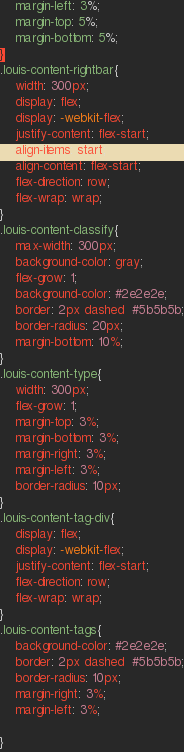<code> <loc_0><loc_0><loc_500><loc_500><_CSS_>    margin-left: 3%;
    margin-top: 5%;
    margin-bottom: 5%;
}
.louis-content-rightbar{
    width: 300px;
    display: flex;
    display: -webkit-flex;
    justify-content: flex-start;
    align-items: start;
    align-content: flex-start;
    flex-direction: row;
    flex-wrap: wrap;
}
.louis-content-classify{
    max-width: 300px;
    background-color: gray;
    flex-grow: 1;
    background-color: #2e2e2e;
    border: 2px dashed  #5b5b5b;
    border-radius: 20px;
    margin-bottom: 10%;
}
.louis-content-type{
    width: 300px;
    flex-grow: 1;
    margin-top: 3%;
    margin-bottom: 3%;
    margin-right: 3%;
    margin-left: 3%;
    border-radius: 10px;
}
.louis-content-tag-div{
    display: flex;
    display: -webkit-flex;
    justify-content: flex-start;
    flex-direction: row;
    flex-wrap: wrap;
}
.louis-content-tags{
    background-color: #2e2e2e;
    border: 2px dashed  #5b5b5b;
    border-radius: 10px;
    margin-right: 3%;
    margin-left: 3%;

}
</code> 